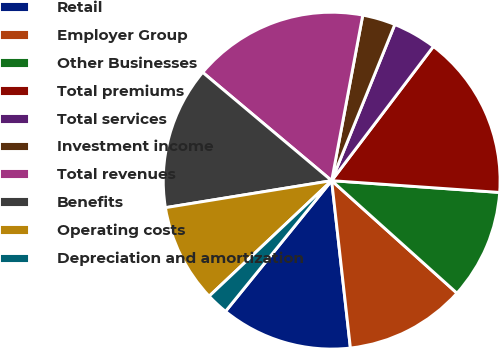<chart> <loc_0><loc_0><loc_500><loc_500><pie_chart><fcel>Retail<fcel>Employer Group<fcel>Other Businesses<fcel>Total premiums<fcel>Total services<fcel>Investment income<fcel>Total revenues<fcel>Benefits<fcel>Operating costs<fcel>Depreciation and amortization<nl><fcel>12.63%<fcel>11.58%<fcel>10.53%<fcel>15.79%<fcel>4.21%<fcel>3.16%<fcel>16.84%<fcel>13.68%<fcel>9.47%<fcel>2.11%<nl></chart> 